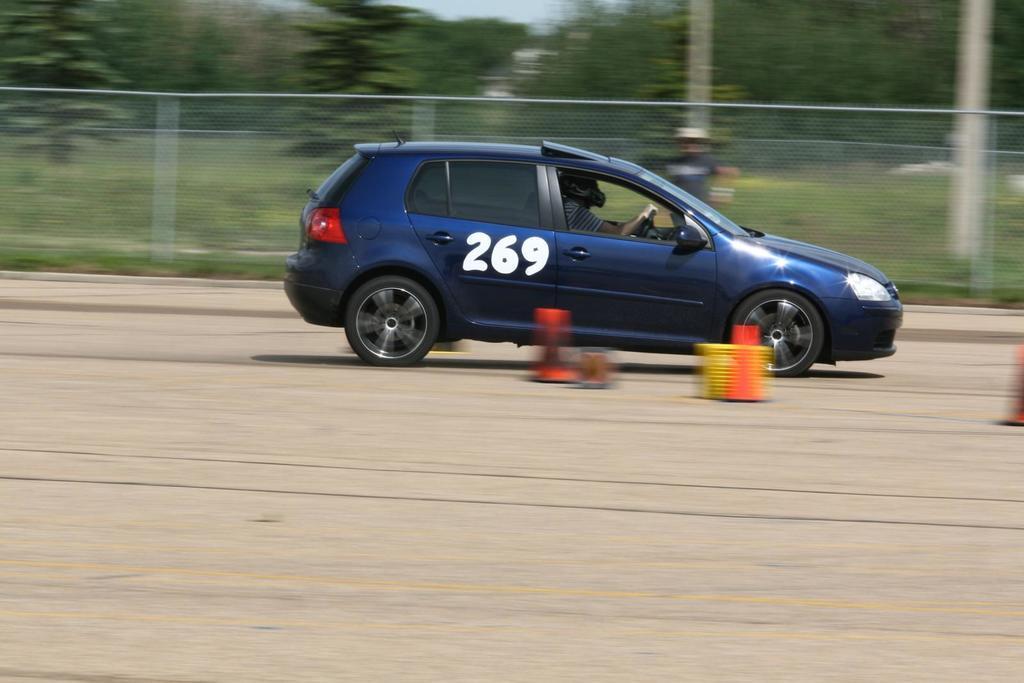Describe this image in one or two sentences. In this image we can see a person sitting in a motor vehicle on the road. In the background we can see grill, trees and sky. 